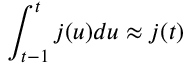Convert formula to latex. <formula><loc_0><loc_0><loc_500><loc_500>\int _ { t - 1 } ^ { t } j ( u ) d u \approx j ( t )</formula> 